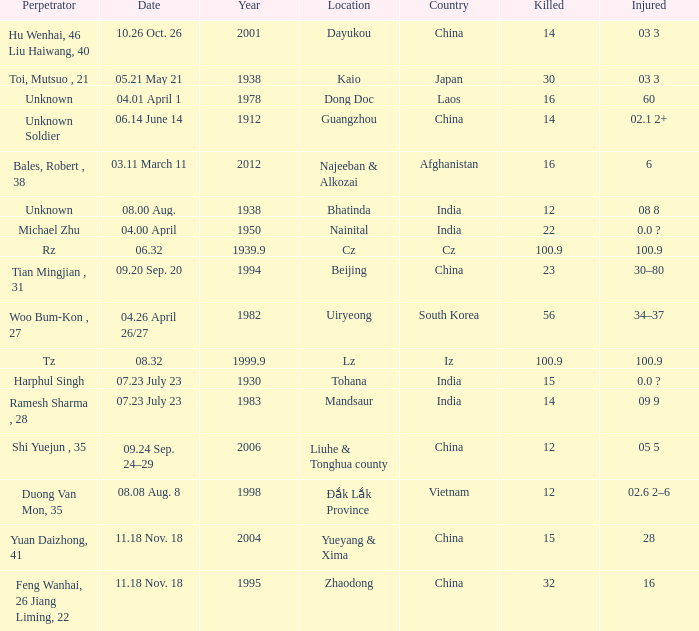What is the average Year, when Date is "04.01 April 1"? 1978.0. 